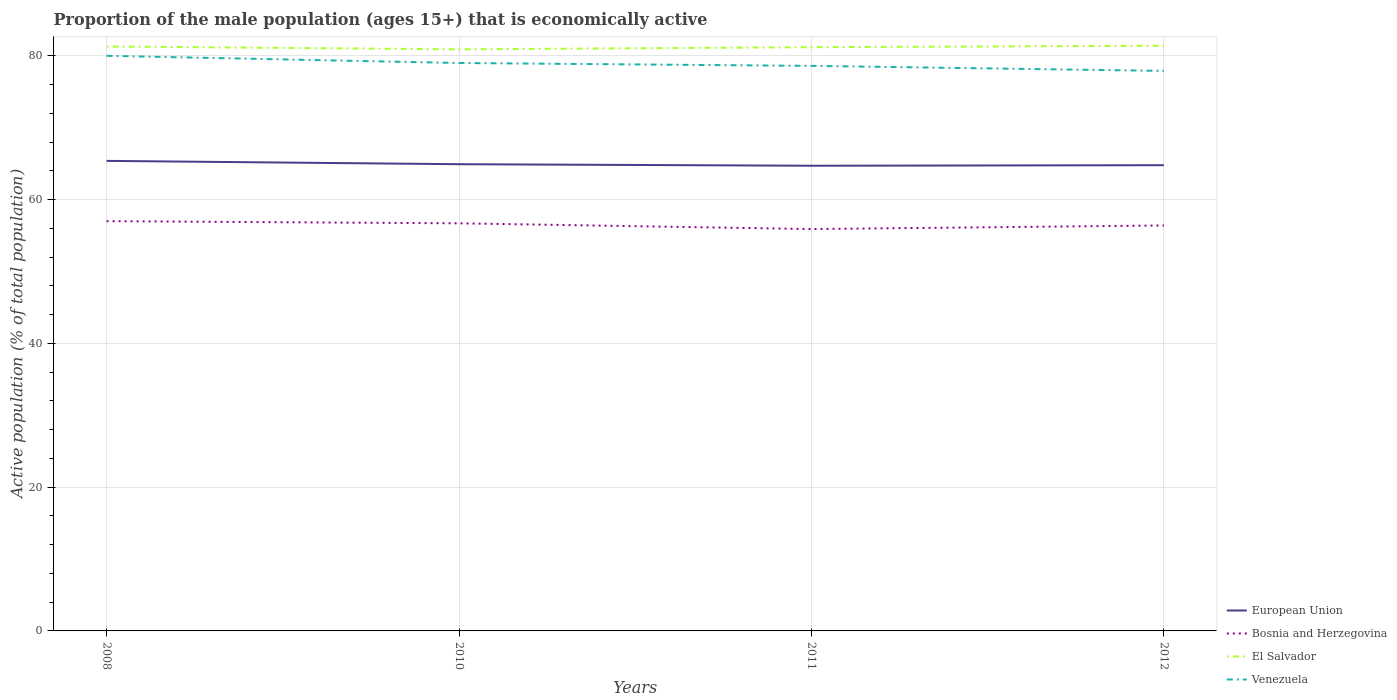How many different coloured lines are there?
Offer a terse response. 4. Is the number of lines equal to the number of legend labels?
Provide a short and direct response. Yes. Across all years, what is the maximum proportion of the male population that is economically active in European Union?
Provide a short and direct response. 64.71. In which year was the proportion of the male population that is economically active in Venezuela maximum?
Your answer should be very brief. 2012. What is the total proportion of the male population that is economically active in El Salvador in the graph?
Keep it short and to the point. 0.4. What is the difference between the highest and the lowest proportion of the male population that is economically active in El Salvador?
Your answer should be very brief. 2. How many lines are there?
Offer a terse response. 4. Does the graph contain grids?
Ensure brevity in your answer.  Yes. How many legend labels are there?
Offer a terse response. 4. How are the legend labels stacked?
Provide a short and direct response. Vertical. What is the title of the graph?
Ensure brevity in your answer.  Proportion of the male population (ages 15+) that is economically active. What is the label or title of the X-axis?
Offer a terse response. Years. What is the label or title of the Y-axis?
Your answer should be compact. Active population (% of total population). What is the Active population (% of total population) of European Union in 2008?
Offer a very short reply. 65.39. What is the Active population (% of total population) in El Salvador in 2008?
Give a very brief answer. 81.3. What is the Active population (% of total population) in European Union in 2010?
Give a very brief answer. 64.92. What is the Active population (% of total population) in Bosnia and Herzegovina in 2010?
Give a very brief answer. 56.7. What is the Active population (% of total population) of El Salvador in 2010?
Ensure brevity in your answer.  80.9. What is the Active population (% of total population) in Venezuela in 2010?
Your response must be concise. 79. What is the Active population (% of total population) of European Union in 2011?
Offer a very short reply. 64.71. What is the Active population (% of total population) in Bosnia and Herzegovina in 2011?
Your response must be concise. 55.9. What is the Active population (% of total population) of El Salvador in 2011?
Give a very brief answer. 81.2. What is the Active population (% of total population) in Venezuela in 2011?
Your answer should be very brief. 78.6. What is the Active population (% of total population) in European Union in 2012?
Offer a very short reply. 64.78. What is the Active population (% of total population) of Bosnia and Herzegovina in 2012?
Provide a succinct answer. 56.4. What is the Active population (% of total population) in El Salvador in 2012?
Your response must be concise. 81.4. What is the Active population (% of total population) in Venezuela in 2012?
Provide a short and direct response. 77.9. Across all years, what is the maximum Active population (% of total population) of European Union?
Make the answer very short. 65.39. Across all years, what is the maximum Active population (% of total population) in El Salvador?
Your answer should be compact. 81.4. Across all years, what is the maximum Active population (% of total population) in Venezuela?
Offer a terse response. 80. Across all years, what is the minimum Active population (% of total population) in European Union?
Offer a very short reply. 64.71. Across all years, what is the minimum Active population (% of total population) in Bosnia and Herzegovina?
Your answer should be very brief. 55.9. Across all years, what is the minimum Active population (% of total population) of El Salvador?
Provide a succinct answer. 80.9. Across all years, what is the minimum Active population (% of total population) of Venezuela?
Make the answer very short. 77.9. What is the total Active population (% of total population) in European Union in the graph?
Give a very brief answer. 259.8. What is the total Active population (% of total population) in Bosnia and Herzegovina in the graph?
Ensure brevity in your answer.  226. What is the total Active population (% of total population) in El Salvador in the graph?
Your answer should be compact. 324.8. What is the total Active population (% of total population) in Venezuela in the graph?
Offer a terse response. 315.5. What is the difference between the Active population (% of total population) in European Union in 2008 and that in 2010?
Provide a succinct answer. 0.46. What is the difference between the Active population (% of total population) in Venezuela in 2008 and that in 2010?
Offer a very short reply. 1. What is the difference between the Active population (% of total population) in European Union in 2008 and that in 2011?
Keep it short and to the point. 0.68. What is the difference between the Active population (% of total population) in El Salvador in 2008 and that in 2011?
Make the answer very short. 0.1. What is the difference between the Active population (% of total population) in European Union in 2008 and that in 2012?
Your response must be concise. 0.6. What is the difference between the Active population (% of total population) of Bosnia and Herzegovina in 2008 and that in 2012?
Ensure brevity in your answer.  0.6. What is the difference between the Active population (% of total population) in Venezuela in 2008 and that in 2012?
Offer a very short reply. 2.1. What is the difference between the Active population (% of total population) of European Union in 2010 and that in 2011?
Offer a very short reply. 0.21. What is the difference between the Active population (% of total population) of European Union in 2010 and that in 2012?
Your response must be concise. 0.14. What is the difference between the Active population (% of total population) in Bosnia and Herzegovina in 2010 and that in 2012?
Your answer should be very brief. 0.3. What is the difference between the Active population (% of total population) in European Union in 2011 and that in 2012?
Your answer should be very brief. -0.08. What is the difference between the Active population (% of total population) in European Union in 2008 and the Active population (% of total population) in Bosnia and Herzegovina in 2010?
Your response must be concise. 8.69. What is the difference between the Active population (% of total population) in European Union in 2008 and the Active population (% of total population) in El Salvador in 2010?
Give a very brief answer. -15.51. What is the difference between the Active population (% of total population) in European Union in 2008 and the Active population (% of total population) in Venezuela in 2010?
Your answer should be very brief. -13.61. What is the difference between the Active population (% of total population) in Bosnia and Herzegovina in 2008 and the Active population (% of total population) in El Salvador in 2010?
Make the answer very short. -23.9. What is the difference between the Active population (% of total population) in European Union in 2008 and the Active population (% of total population) in Bosnia and Herzegovina in 2011?
Provide a succinct answer. 9.49. What is the difference between the Active population (% of total population) in European Union in 2008 and the Active population (% of total population) in El Salvador in 2011?
Your answer should be very brief. -15.81. What is the difference between the Active population (% of total population) in European Union in 2008 and the Active population (% of total population) in Venezuela in 2011?
Make the answer very short. -13.21. What is the difference between the Active population (% of total population) in Bosnia and Herzegovina in 2008 and the Active population (% of total population) in El Salvador in 2011?
Keep it short and to the point. -24.2. What is the difference between the Active population (% of total population) of Bosnia and Herzegovina in 2008 and the Active population (% of total population) of Venezuela in 2011?
Offer a terse response. -21.6. What is the difference between the Active population (% of total population) in El Salvador in 2008 and the Active population (% of total population) in Venezuela in 2011?
Your answer should be very brief. 2.7. What is the difference between the Active population (% of total population) of European Union in 2008 and the Active population (% of total population) of Bosnia and Herzegovina in 2012?
Make the answer very short. 8.99. What is the difference between the Active population (% of total population) in European Union in 2008 and the Active population (% of total population) in El Salvador in 2012?
Provide a short and direct response. -16.01. What is the difference between the Active population (% of total population) in European Union in 2008 and the Active population (% of total population) in Venezuela in 2012?
Provide a succinct answer. -12.51. What is the difference between the Active population (% of total population) of Bosnia and Herzegovina in 2008 and the Active population (% of total population) of El Salvador in 2012?
Make the answer very short. -24.4. What is the difference between the Active population (% of total population) in Bosnia and Herzegovina in 2008 and the Active population (% of total population) in Venezuela in 2012?
Make the answer very short. -20.9. What is the difference between the Active population (% of total population) of El Salvador in 2008 and the Active population (% of total population) of Venezuela in 2012?
Keep it short and to the point. 3.4. What is the difference between the Active population (% of total population) of European Union in 2010 and the Active population (% of total population) of Bosnia and Herzegovina in 2011?
Provide a short and direct response. 9.02. What is the difference between the Active population (% of total population) of European Union in 2010 and the Active population (% of total population) of El Salvador in 2011?
Ensure brevity in your answer.  -16.28. What is the difference between the Active population (% of total population) in European Union in 2010 and the Active population (% of total population) in Venezuela in 2011?
Make the answer very short. -13.68. What is the difference between the Active population (% of total population) in Bosnia and Herzegovina in 2010 and the Active population (% of total population) in El Salvador in 2011?
Your answer should be very brief. -24.5. What is the difference between the Active population (% of total population) in Bosnia and Herzegovina in 2010 and the Active population (% of total population) in Venezuela in 2011?
Your response must be concise. -21.9. What is the difference between the Active population (% of total population) of El Salvador in 2010 and the Active population (% of total population) of Venezuela in 2011?
Make the answer very short. 2.3. What is the difference between the Active population (% of total population) in European Union in 2010 and the Active population (% of total population) in Bosnia and Herzegovina in 2012?
Keep it short and to the point. 8.52. What is the difference between the Active population (% of total population) in European Union in 2010 and the Active population (% of total population) in El Salvador in 2012?
Your response must be concise. -16.48. What is the difference between the Active population (% of total population) of European Union in 2010 and the Active population (% of total population) of Venezuela in 2012?
Make the answer very short. -12.98. What is the difference between the Active population (% of total population) of Bosnia and Herzegovina in 2010 and the Active population (% of total population) of El Salvador in 2012?
Keep it short and to the point. -24.7. What is the difference between the Active population (% of total population) in Bosnia and Herzegovina in 2010 and the Active population (% of total population) in Venezuela in 2012?
Make the answer very short. -21.2. What is the difference between the Active population (% of total population) in European Union in 2011 and the Active population (% of total population) in Bosnia and Herzegovina in 2012?
Give a very brief answer. 8.31. What is the difference between the Active population (% of total population) in European Union in 2011 and the Active population (% of total population) in El Salvador in 2012?
Offer a terse response. -16.69. What is the difference between the Active population (% of total population) of European Union in 2011 and the Active population (% of total population) of Venezuela in 2012?
Provide a succinct answer. -13.19. What is the difference between the Active population (% of total population) of Bosnia and Herzegovina in 2011 and the Active population (% of total population) of El Salvador in 2012?
Your answer should be compact. -25.5. What is the difference between the Active population (% of total population) of Bosnia and Herzegovina in 2011 and the Active population (% of total population) of Venezuela in 2012?
Provide a succinct answer. -22. What is the difference between the Active population (% of total population) in El Salvador in 2011 and the Active population (% of total population) in Venezuela in 2012?
Your answer should be compact. 3.3. What is the average Active population (% of total population) of European Union per year?
Provide a short and direct response. 64.95. What is the average Active population (% of total population) in Bosnia and Herzegovina per year?
Ensure brevity in your answer.  56.5. What is the average Active population (% of total population) in El Salvador per year?
Give a very brief answer. 81.2. What is the average Active population (% of total population) of Venezuela per year?
Your answer should be very brief. 78.88. In the year 2008, what is the difference between the Active population (% of total population) of European Union and Active population (% of total population) of Bosnia and Herzegovina?
Provide a short and direct response. 8.39. In the year 2008, what is the difference between the Active population (% of total population) of European Union and Active population (% of total population) of El Salvador?
Give a very brief answer. -15.91. In the year 2008, what is the difference between the Active population (% of total population) in European Union and Active population (% of total population) in Venezuela?
Offer a terse response. -14.61. In the year 2008, what is the difference between the Active population (% of total population) of Bosnia and Herzegovina and Active population (% of total population) of El Salvador?
Your response must be concise. -24.3. In the year 2008, what is the difference between the Active population (% of total population) in Bosnia and Herzegovina and Active population (% of total population) in Venezuela?
Offer a very short reply. -23. In the year 2008, what is the difference between the Active population (% of total population) of El Salvador and Active population (% of total population) of Venezuela?
Make the answer very short. 1.3. In the year 2010, what is the difference between the Active population (% of total population) in European Union and Active population (% of total population) in Bosnia and Herzegovina?
Your answer should be compact. 8.22. In the year 2010, what is the difference between the Active population (% of total population) in European Union and Active population (% of total population) in El Salvador?
Give a very brief answer. -15.98. In the year 2010, what is the difference between the Active population (% of total population) in European Union and Active population (% of total population) in Venezuela?
Offer a terse response. -14.08. In the year 2010, what is the difference between the Active population (% of total population) in Bosnia and Herzegovina and Active population (% of total population) in El Salvador?
Ensure brevity in your answer.  -24.2. In the year 2010, what is the difference between the Active population (% of total population) of Bosnia and Herzegovina and Active population (% of total population) of Venezuela?
Make the answer very short. -22.3. In the year 2011, what is the difference between the Active population (% of total population) of European Union and Active population (% of total population) of Bosnia and Herzegovina?
Give a very brief answer. 8.81. In the year 2011, what is the difference between the Active population (% of total population) of European Union and Active population (% of total population) of El Salvador?
Offer a terse response. -16.49. In the year 2011, what is the difference between the Active population (% of total population) of European Union and Active population (% of total population) of Venezuela?
Offer a very short reply. -13.89. In the year 2011, what is the difference between the Active population (% of total population) of Bosnia and Herzegovina and Active population (% of total population) of El Salvador?
Make the answer very short. -25.3. In the year 2011, what is the difference between the Active population (% of total population) in Bosnia and Herzegovina and Active population (% of total population) in Venezuela?
Your response must be concise. -22.7. In the year 2012, what is the difference between the Active population (% of total population) of European Union and Active population (% of total population) of Bosnia and Herzegovina?
Your answer should be very brief. 8.38. In the year 2012, what is the difference between the Active population (% of total population) of European Union and Active population (% of total population) of El Salvador?
Make the answer very short. -16.62. In the year 2012, what is the difference between the Active population (% of total population) in European Union and Active population (% of total population) in Venezuela?
Provide a short and direct response. -13.12. In the year 2012, what is the difference between the Active population (% of total population) in Bosnia and Herzegovina and Active population (% of total population) in El Salvador?
Provide a succinct answer. -25. In the year 2012, what is the difference between the Active population (% of total population) of Bosnia and Herzegovina and Active population (% of total population) of Venezuela?
Make the answer very short. -21.5. In the year 2012, what is the difference between the Active population (% of total population) in El Salvador and Active population (% of total population) in Venezuela?
Offer a very short reply. 3.5. What is the ratio of the Active population (% of total population) of European Union in 2008 to that in 2010?
Keep it short and to the point. 1.01. What is the ratio of the Active population (% of total population) in Bosnia and Herzegovina in 2008 to that in 2010?
Give a very brief answer. 1.01. What is the ratio of the Active population (% of total population) in El Salvador in 2008 to that in 2010?
Your answer should be compact. 1. What is the ratio of the Active population (% of total population) of Venezuela in 2008 to that in 2010?
Provide a succinct answer. 1.01. What is the ratio of the Active population (% of total population) in European Union in 2008 to that in 2011?
Your response must be concise. 1.01. What is the ratio of the Active population (% of total population) of Bosnia and Herzegovina in 2008 to that in 2011?
Your answer should be very brief. 1.02. What is the ratio of the Active population (% of total population) of El Salvador in 2008 to that in 2011?
Make the answer very short. 1. What is the ratio of the Active population (% of total population) of Venezuela in 2008 to that in 2011?
Ensure brevity in your answer.  1.02. What is the ratio of the Active population (% of total population) in European Union in 2008 to that in 2012?
Give a very brief answer. 1.01. What is the ratio of the Active population (% of total population) of Bosnia and Herzegovina in 2008 to that in 2012?
Provide a succinct answer. 1.01. What is the ratio of the Active population (% of total population) of El Salvador in 2008 to that in 2012?
Give a very brief answer. 1. What is the ratio of the Active population (% of total population) in European Union in 2010 to that in 2011?
Make the answer very short. 1. What is the ratio of the Active population (% of total population) of Bosnia and Herzegovina in 2010 to that in 2011?
Provide a short and direct response. 1.01. What is the ratio of the Active population (% of total population) of El Salvador in 2010 to that in 2011?
Your response must be concise. 1. What is the ratio of the Active population (% of total population) of Venezuela in 2010 to that in 2011?
Your answer should be very brief. 1.01. What is the ratio of the Active population (% of total population) in Bosnia and Herzegovina in 2010 to that in 2012?
Make the answer very short. 1.01. What is the ratio of the Active population (% of total population) of El Salvador in 2010 to that in 2012?
Offer a terse response. 0.99. What is the ratio of the Active population (% of total population) in Venezuela in 2010 to that in 2012?
Ensure brevity in your answer.  1.01. What is the ratio of the Active population (% of total population) in European Union in 2011 to that in 2012?
Ensure brevity in your answer.  1. What is the ratio of the Active population (% of total population) of Bosnia and Herzegovina in 2011 to that in 2012?
Offer a very short reply. 0.99. What is the difference between the highest and the second highest Active population (% of total population) of European Union?
Your response must be concise. 0.46. What is the difference between the highest and the lowest Active population (% of total population) in European Union?
Offer a very short reply. 0.68. What is the difference between the highest and the lowest Active population (% of total population) of Bosnia and Herzegovina?
Offer a very short reply. 1.1. What is the difference between the highest and the lowest Active population (% of total population) of Venezuela?
Keep it short and to the point. 2.1. 